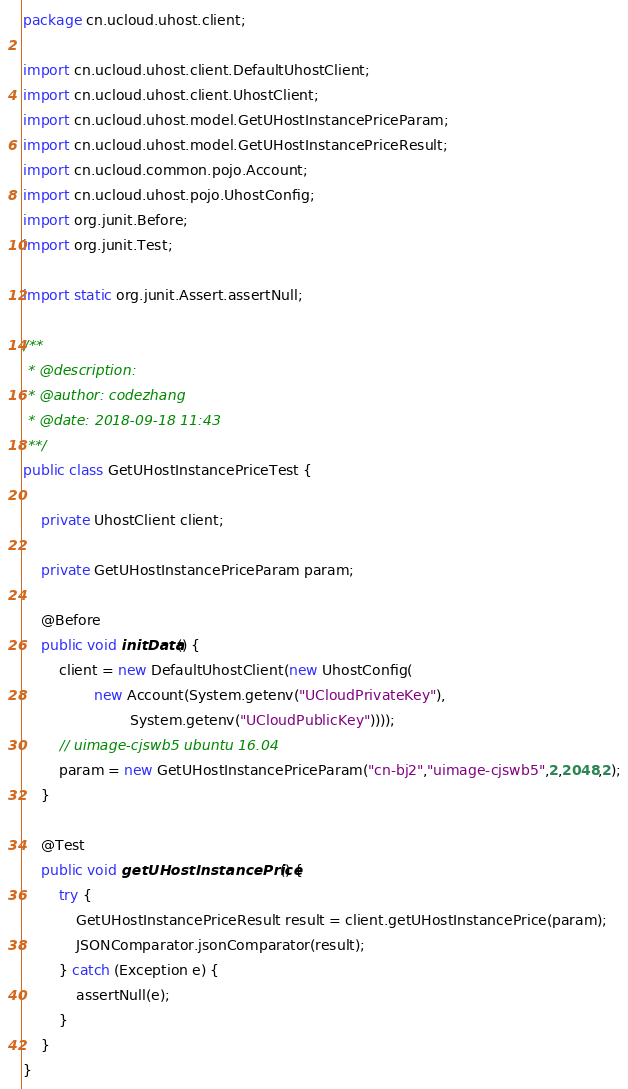<code> <loc_0><loc_0><loc_500><loc_500><_Java_>package cn.ucloud.uhost.client;

import cn.ucloud.uhost.client.DefaultUhostClient;
import cn.ucloud.uhost.client.UhostClient;
import cn.ucloud.uhost.model.GetUHostInstancePriceParam;
import cn.ucloud.uhost.model.GetUHostInstancePriceResult;
import cn.ucloud.common.pojo.Account;
import cn.ucloud.uhost.pojo.UhostConfig;
import org.junit.Before;
import org.junit.Test;

import static org.junit.Assert.assertNull;

/**
 * @description:
 * @author: codezhang
 * @date: 2018-09-18 11:43
 **/
public class GetUHostInstancePriceTest {

    private UhostClient client;

    private GetUHostInstancePriceParam param;

    @Before
    public void initData() {
        client = new DefaultUhostClient(new UhostConfig(
                new Account(System.getenv("UCloudPrivateKey"),
                        System.getenv("UCloudPublicKey"))));
        // uimage-cjswb5 ubuntu 16.04
        param = new GetUHostInstancePriceParam("cn-bj2","uimage-cjswb5",2,2048,2);
    }

    @Test
    public void getUHostInstancePrice() {
        try {
            GetUHostInstancePriceResult result = client.getUHostInstancePrice(param);
            JSONComparator.jsonComparator(result);
        } catch (Exception e) {
            assertNull(e);
        }
    }
}</code> 